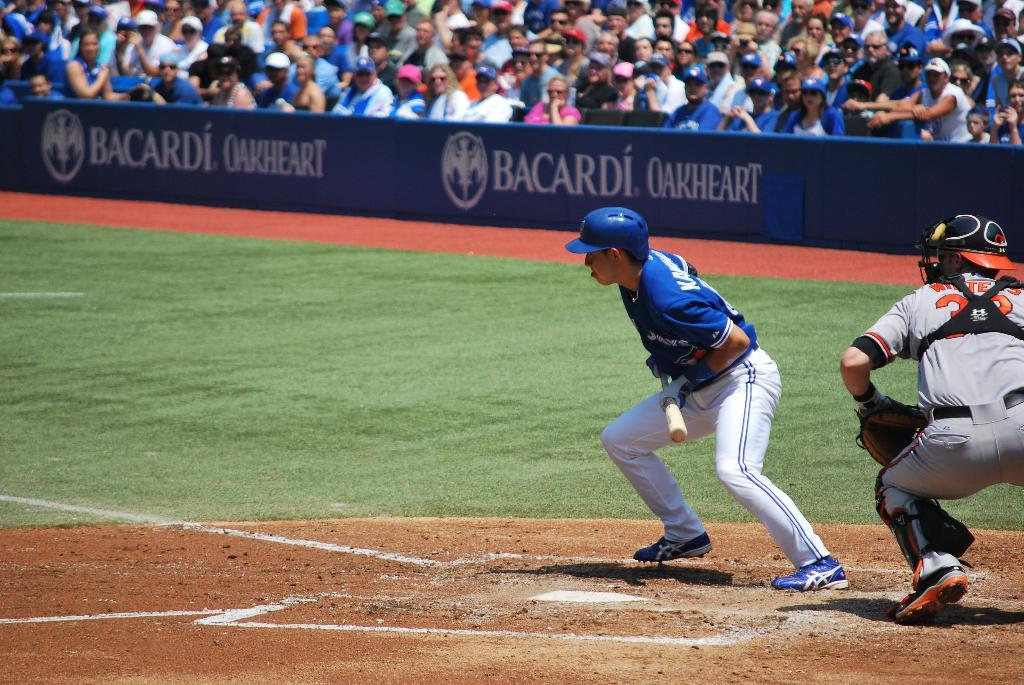<image>
Share a concise interpretation of the image provided. The Blue Jays and another team are playing baseball in a packed stadium and Bacardi Oakheart is advertised on the fence in front of the seats. 